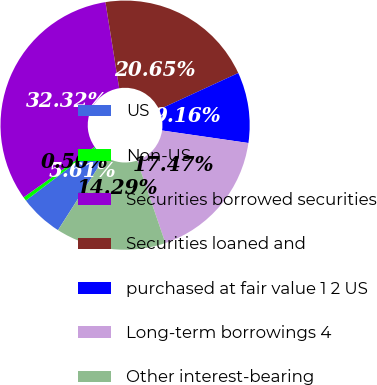Convert chart. <chart><loc_0><loc_0><loc_500><loc_500><pie_chart><fcel>US<fcel>Non-US<fcel>Securities borrowed securities<fcel>Securities loaned and<fcel>purchased at fair value 1 2 US<fcel>Long-term borrowings 4<fcel>Other interest-bearing<nl><fcel>5.61%<fcel>0.5%<fcel>32.32%<fcel>20.65%<fcel>9.16%<fcel>17.47%<fcel>14.29%<nl></chart> 